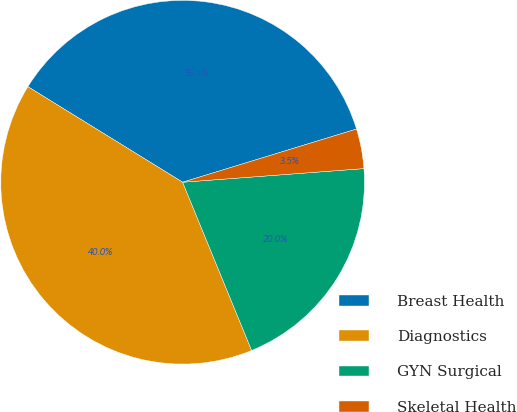Convert chart. <chart><loc_0><loc_0><loc_500><loc_500><pie_chart><fcel>Breast Health<fcel>Diagnostics<fcel>GYN Surgical<fcel>Skeletal Health<nl><fcel>36.47%<fcel>40.0%<fcel>20.0%<fcel>3.53%<nl></chart> 